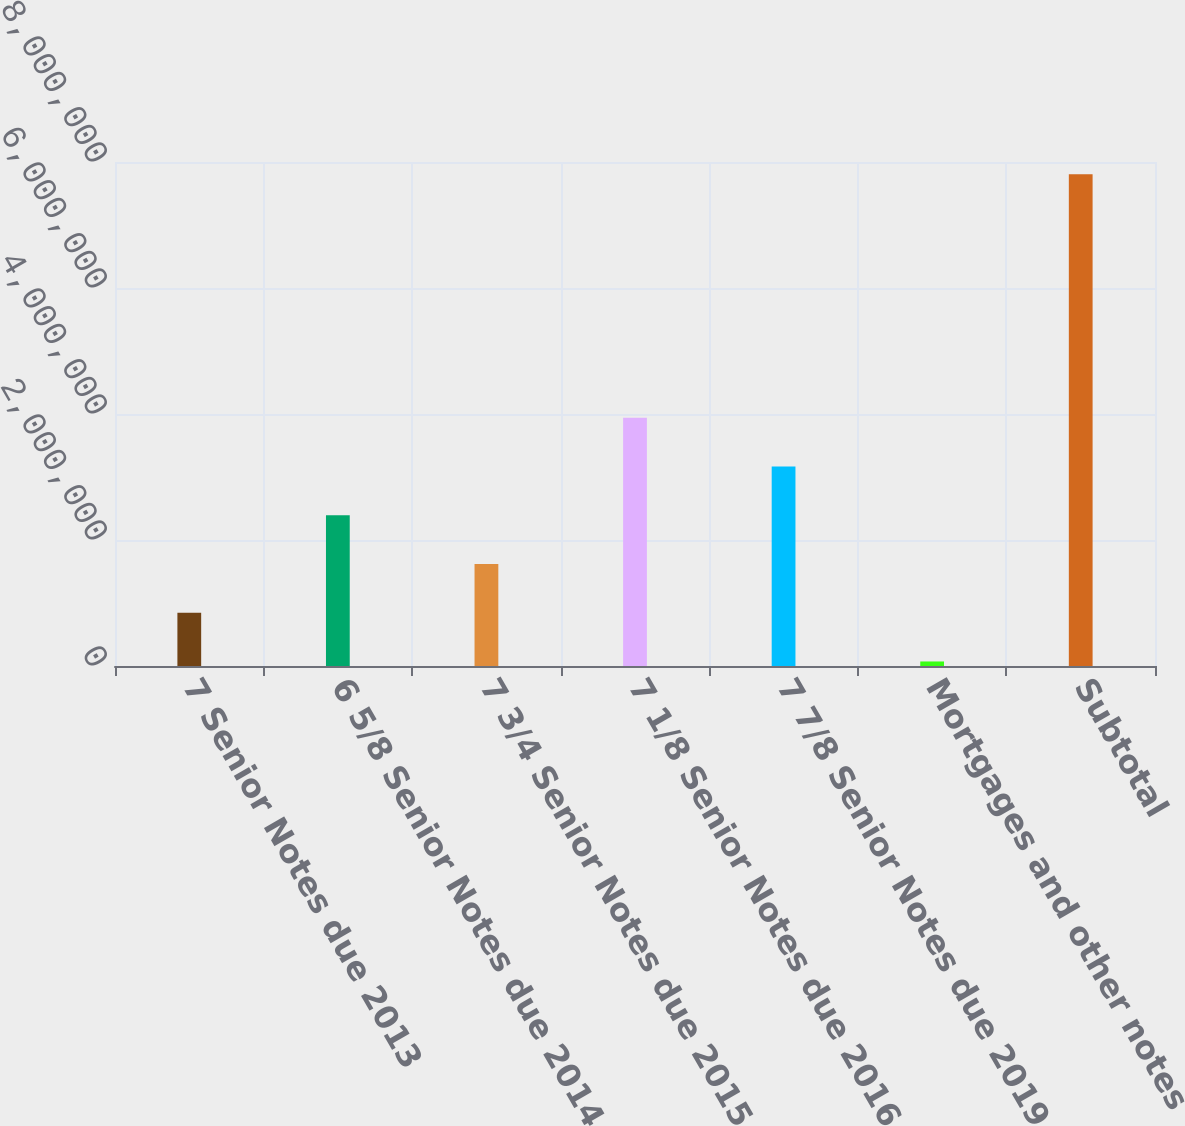<chart> <loc_0><loc_0><loc_500><loc_500><bar_chart><fcel>7 Senior Notes due 2013<fcel>6 5/8 Senior Notes due 2014<fcel>7 3/4 Senior Notes due 2015<fcel>7 1/8 Senior Notes due 2016<fcel>7 7/8 Senior Notes due 2019<fcel>Mortgages and other notes<fcel>Subtotal<nl><fcel>845396<fcel>2.39245e+06<fcel>1.61892e+06<fcel>3.9395e+06<fcel>3.16597e+06<fcel>71871<fcel>7.80712e+06<nl></chart> 